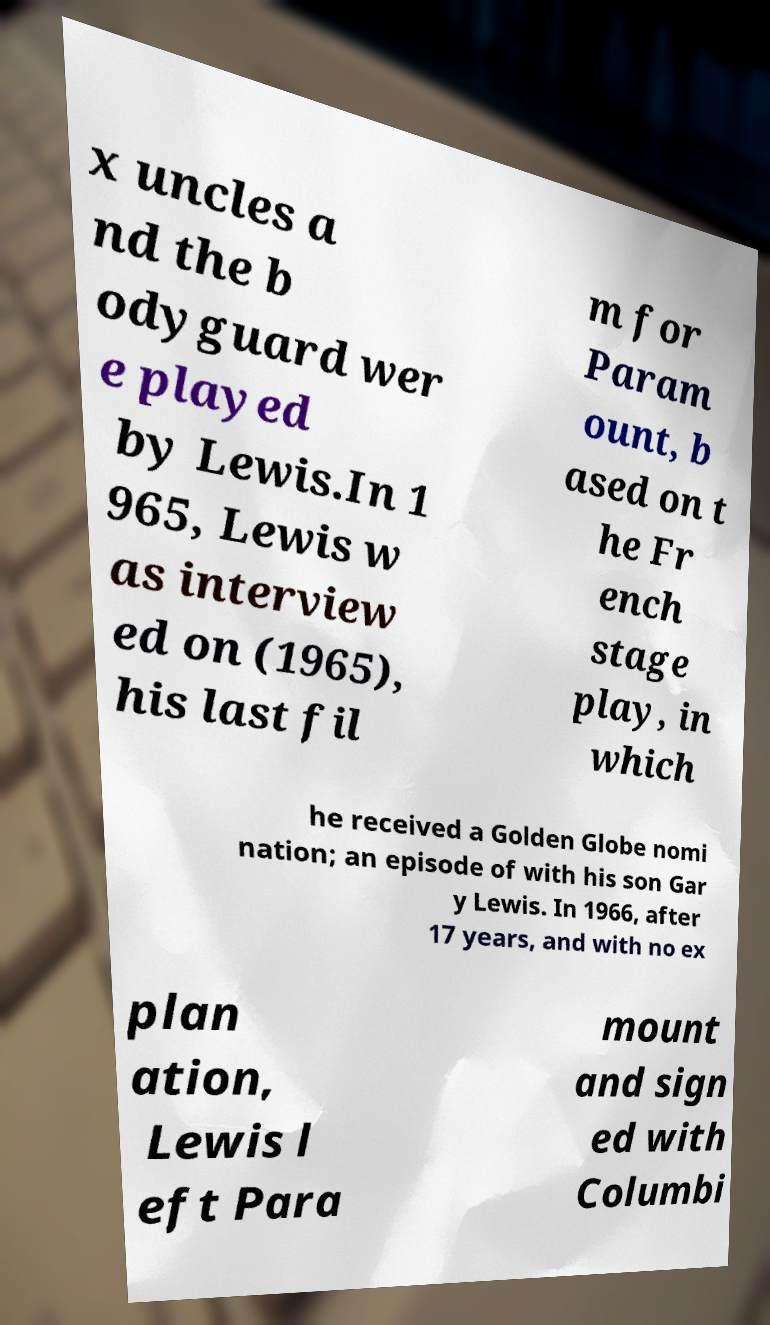Could you assist in decoding the text presented in this image and type it out clearly? x uncles a nd the b odyguard wer e played by Lewis.In 1 965, Lewis w as interview ed on (1965), his last fil m for Param ount, b ased on t he Fr ench stage play, in which he received a Golden Globe nomi nation; an episode of with his son Gar y Lewis. In 1966, after 17 years, and with no ex plan ation, Lewis l eft Para mount and sign ed with Columbi 